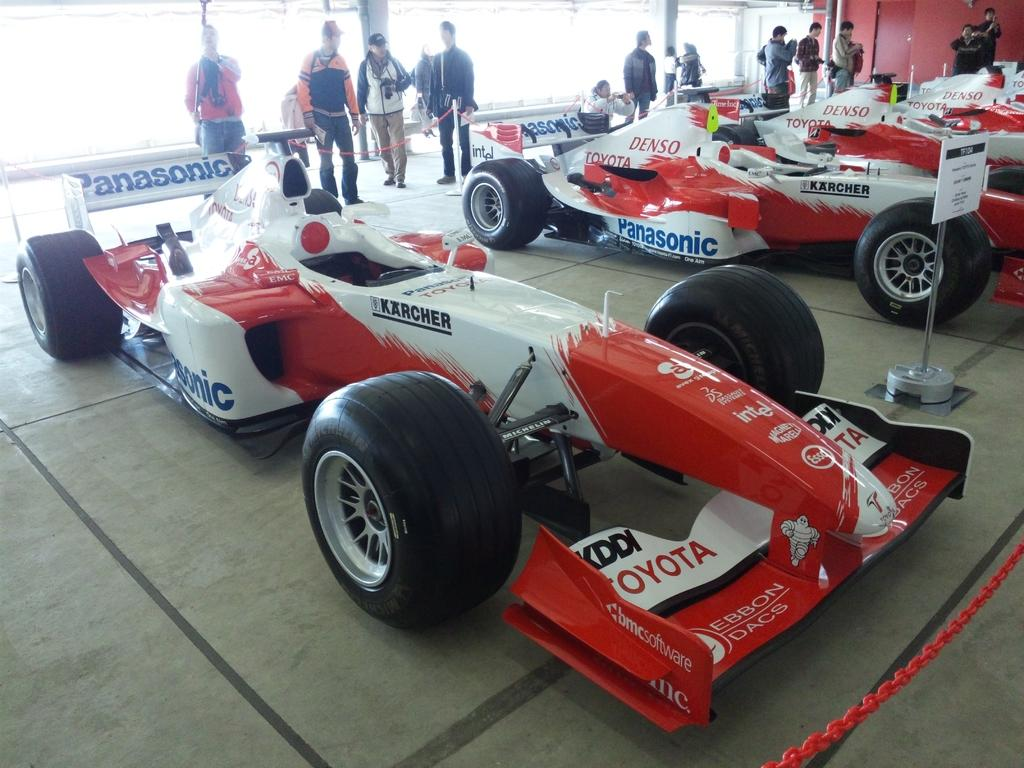What types of objects are present in the image? There are vehicles, people on the floor, boards, a chain, and a rod in the image. What can be seen in the background of the image? There is a wall and glasses in the background of the image. What type of education is being provided by the band in the image? There is no band present in the image, so it is not possible to determine what type of education they might be providing. 